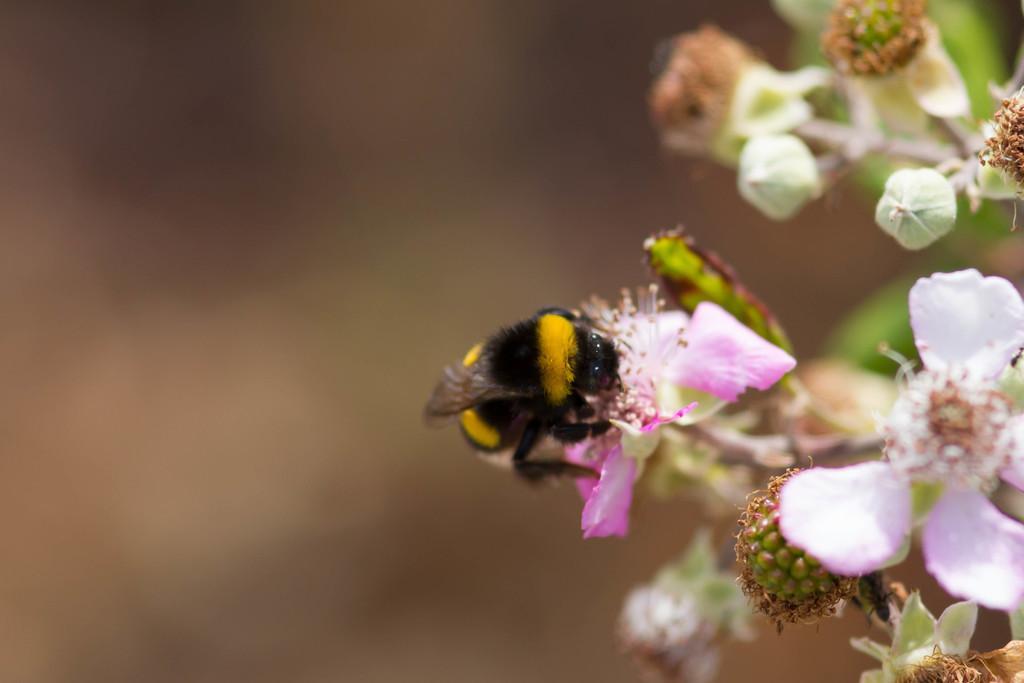In one or two sentences, can you explain what this image depicts? In this picture we can see an insect, flowers, buds, leaves and in the background it is blurry. 